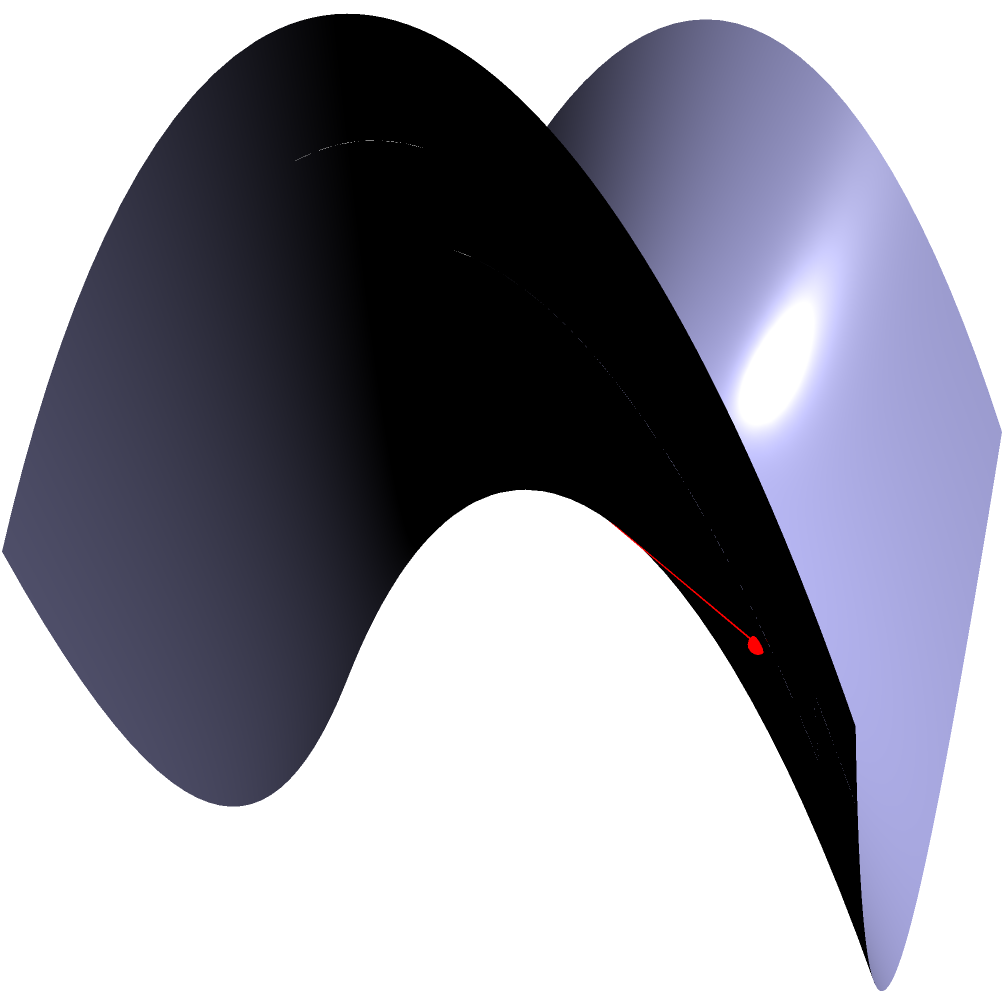In the context of international diplomacy, understanding complex relationships often requires non-linear thinking. Consider the saddle-shaped surface shown above, which could represent a geopolitical landscape. Two points A and B are marked on this surface. What can be said about the shortest path (geodesic) between these two points in relation to the straight line connecting them? To understand the shortest path (geodesic) between two points on a saddle-shaped surface, let's follow these steps:

1. Surface shape: The surface shown is a hyperbolic paraboloid, described by the equation $z = x^2 - y^2$. This shape is relevant in diplomacy as it can represent complex, non-linear relationships between countries or issues.

2. Straight line vs. geodesic: The red line represents the straight line connecting points A and B. In Euclidean geometry, this would be the shortest path. However, on curved surfaces, the shortest path (geodesic) often differs from the straight line.

3. Properties of geodesics on a saddle surface:
   a. They tend to curve away from the center of the saddle.
   b. They minimize the total distance traveled along the surface.

4. Observation: The green dashed line represents the geodesic between A and B. Notice how it curves away from the center of the saddle, unlike the straight red line.

5. Comparison: The geodesic (green) is clearly longer in three-dimensional space than the straight line (red). However, if we were to "unfold" the surface, the geodesic would be the shortest path along the surface between the two points.

6. Diplomatic analogy: In international relations, the "straight line" approach (direct action) might seem shortest, but the "geodesic" approach (considering the complexities of the geopolitical landscape) often leads to more effective long-term solutions.
Answer: The geodesic curves away from the straight line and is longer in 3D space but shorter along the surface. 